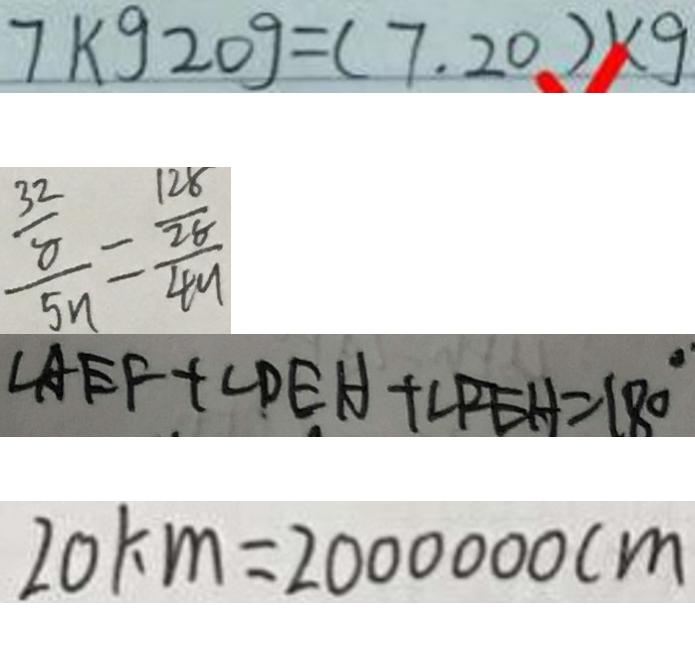Convert formula to latex. <formula><loc_0><loc_0><loc_500><loc_500>7 k g 2 0 g = ( 7 . 2 0 ) K g 
 \frac { \frac { 3 2 } { 8 } } { 5 n } = \frac { \frac { 1 2 8 } { 2 8 } } { 4 9 } 
 \angle A E F + \angle D E H + \angle P E H = 1 8 0 ^ { \circ } 
 2 0 k m = 2 0 0 0 0 0 0 c m</formula> 